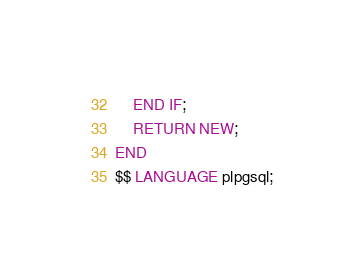Convert code to text. <code><loc_0><loc_0><loc_500><loc_500><_SQL_>    END IF;
    RETURN NEW;
END
$$ LANGUAGE plpgsql;

</code> 